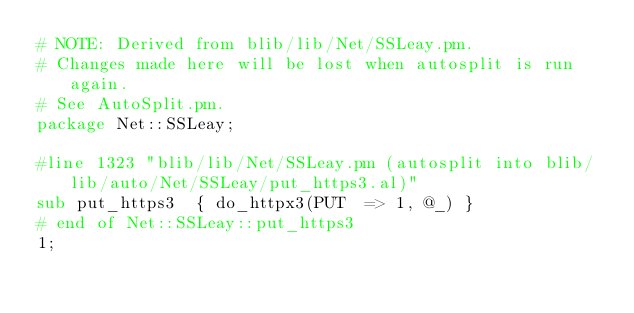Convert code to text. <code><loc_0><loc_0><loc_500><loc_500><_Perl_># NOTE: Derived from blib/lib/Net/SSLeay.pm.
# Changes made here will be lost when autosplit is run again.
# See AutoSplit.pm.
package Net::SSLeay;

#line 1323 "blib/lib/Net/SSLeay.pm (autosplit into blib/lib/auto/Net/SSLeay/put_https3.al)"
sub put_https3  { do_httpx3(PUT  => 1, @_) }
# end of Net::SSLeay::put_https3
1;
</code> 